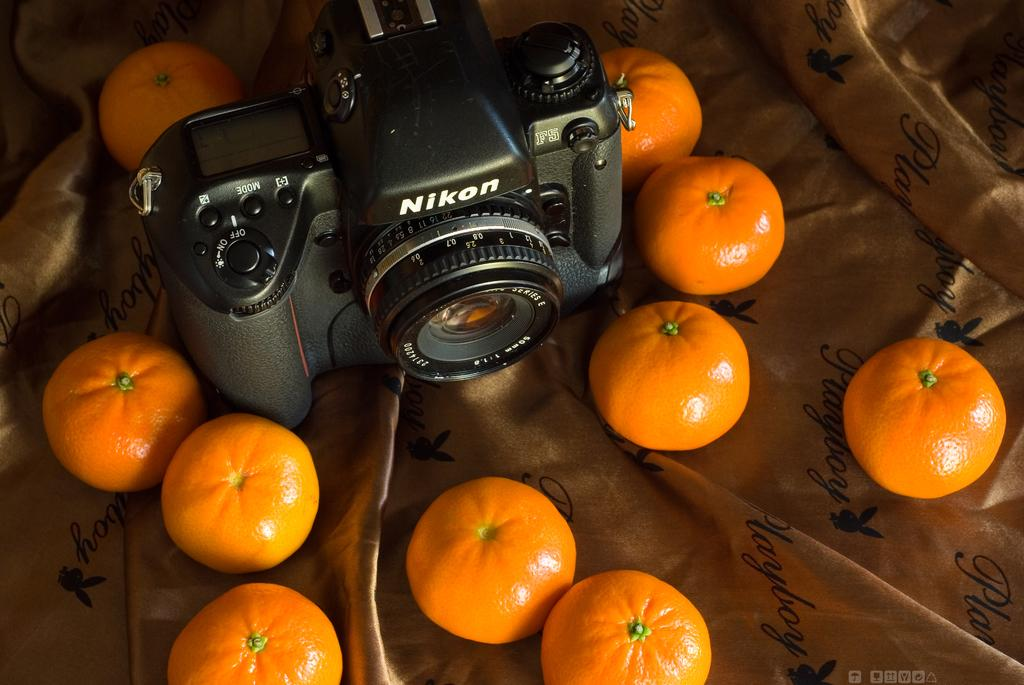What type of camera is visible in the image? There is a black color camera in the image. What objects are placed on the cloth in the image? There are oranges on a cloth in the image. Where is the root of the orange tree in the image? There is no orange tree present in the image, only oranges on a cloth. What type of attraction is depicted in the image? There is no attraction depicted in the image; it features a black color camera and oranges on a cloth. 